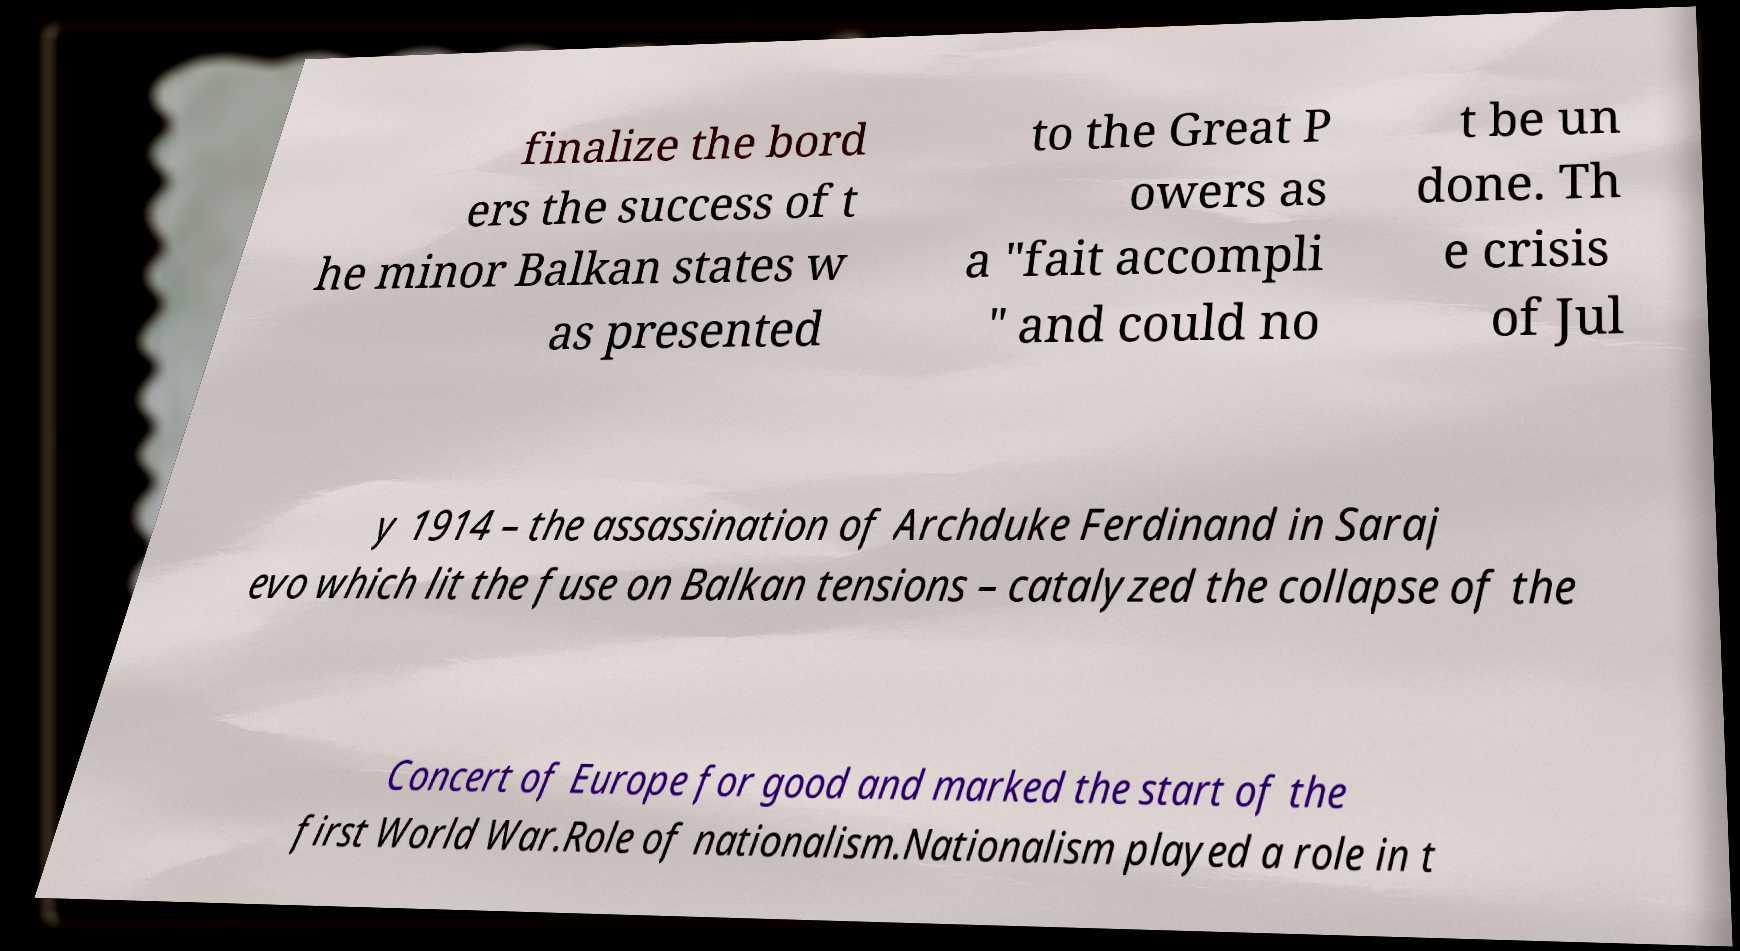Can you read and provide the text displayed in the image?This photo seems to have some interesting text. Can you extract and type it out for me? finalize the bord ers the success of t he minor Balkan states w as presented to the Great P owers as a "fait accompli " and could no t be un done. Th e crisis of Jul y 1914 – the assassination of Archduke Ferdinand in Saraj evo which lit the fuse on Balkan tensions – catalyzed the collapse of the Concert of Europe for good and marked the start of the first World War.Role of nationalism.Nationalism played a role in t 